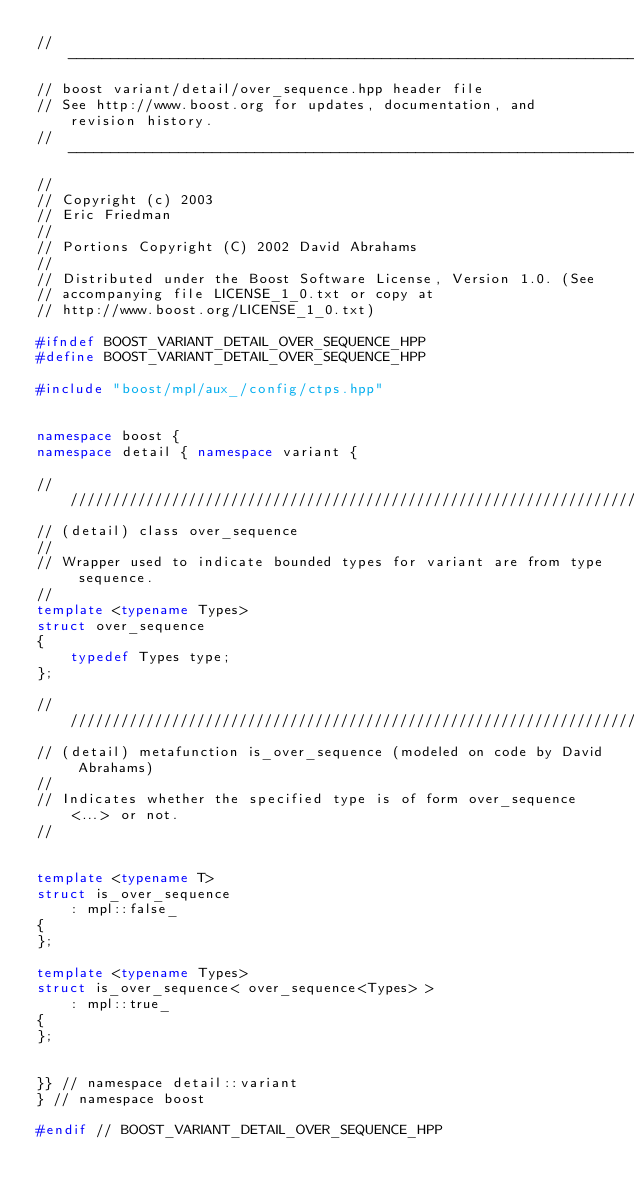<code> <loc_0><loc_0><loc_500><loc_500><_C++_>//-----------------------------------------------------------------------------
// boost variant/detail/over_sequence.hpp header file
// See http://www.boost.org for updates, documentation, and revision history.
//-----------------------------------------------------------------------------
//
// Copyright (c) 2003
// Eric Friedman
//
// Portions Copyright (C) 2002 David Abrahams
//
// Distributed under the Boost Software License, Version 1.0. (See
// accompanying file LICENSE_1_0.txt or copy at
// http://www.boost.org/LICENSE_1_0.txt)

#ifndef BOOST_VARIANT_DETAIL_OVER_SEQUENCE_HPP
#define BOOST_VARIANT_DETAIL_OVER_SEQUENCE_HPP

#include "boost/mpl/aux_/config/ctps.hpp"


namespace boost {
namespace detail { namespace variant {

///////////////////////////////////////////////////////////////////////////////
// (detail) class over_sequence
//
// Wrapper used to indicate bounded types for variant are from type sequence.
//
template <typename Types>
struct over_sequence
{
    typedef Types type;
};

///////////////////////////////////////////////////////////////////////////////
// (detail) metafunction is_over_sequence (modeled on code by David Abrahams)
//
// Indicates whether the specified type is of form over_sequence<...> or not.
//


template <typename T>
struct is_over_sequence
    : mpl::false_
{
};

template <typename Types>
struct is_over_sequence< over_sequence<Types> >
    : mpl::true_
{
};


}} // namespace detail::variant
} // namespace boost

#endif // BOOST_VARIANT_DETAIL_OVER_SEQUENCE_HPP
</code> 